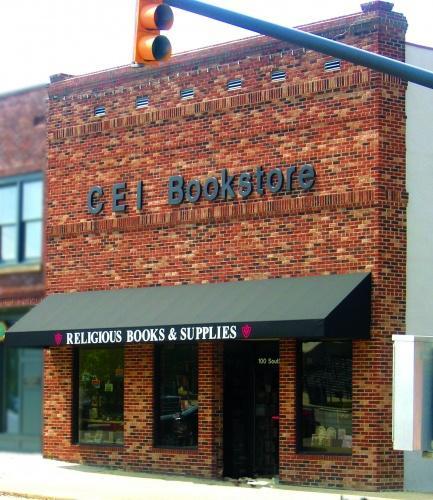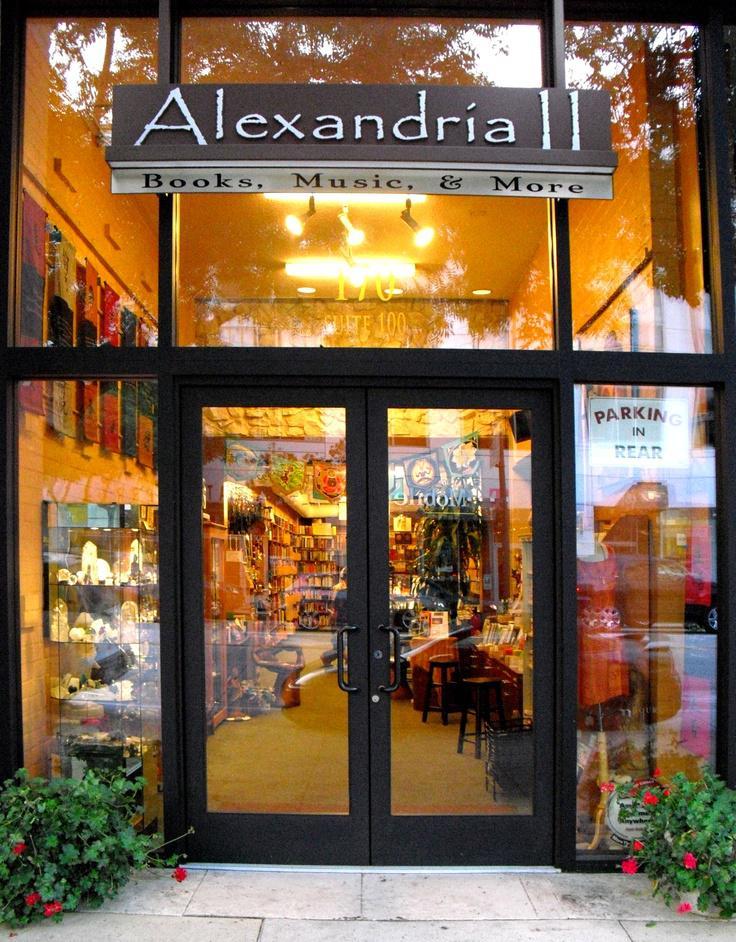The first image is the image on the left, the second image is the image on the right. Given the left and right images, does the statement "In at least one image there is a brick store with at least three window and a black awning." hold true? Answer yes or no. Yes. The first image is the image on the left, the second image is the image on the right. Examine the images to the left and right. Is the description "The bookstores are all brightly lit up on the inside." accurate? Answer yes or no. No. 